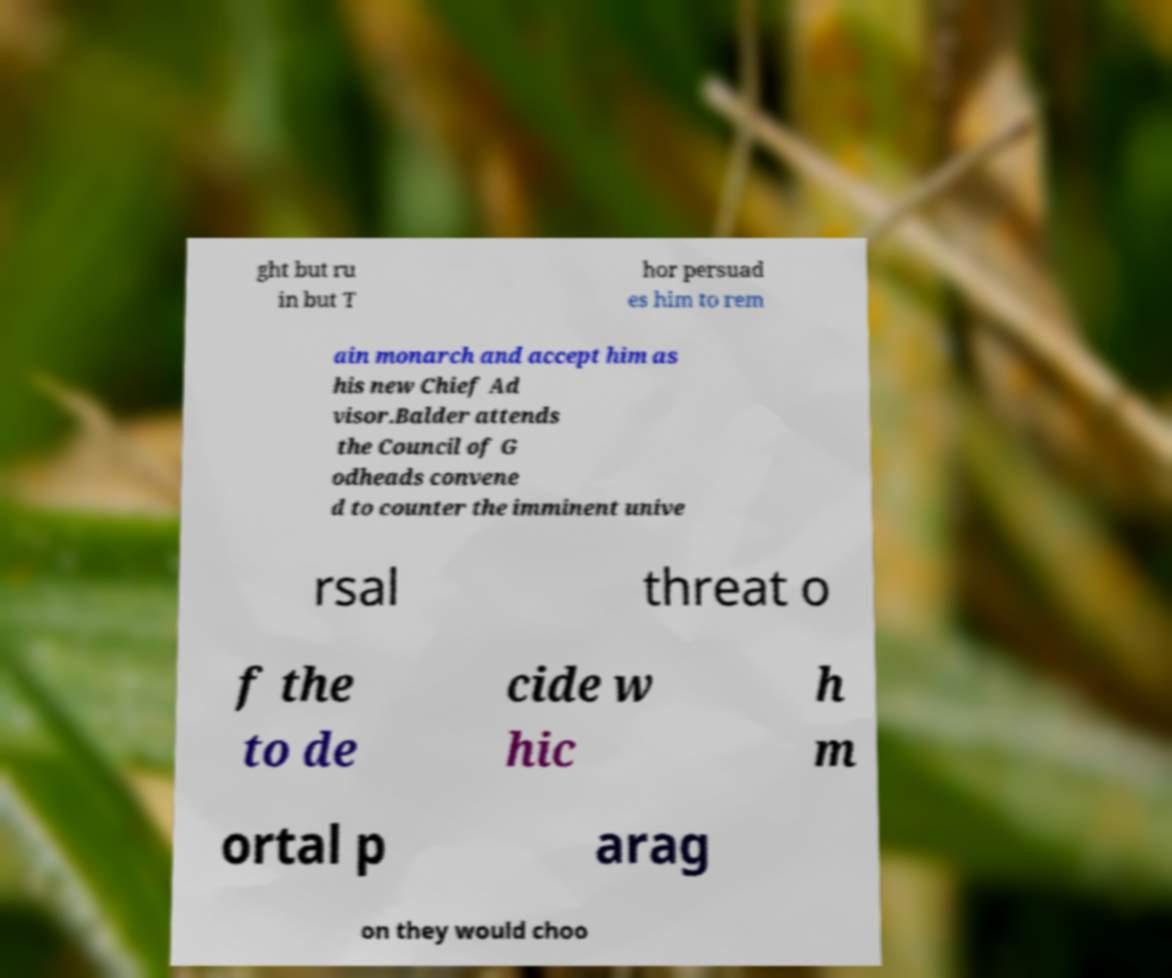Please read and relay the text visible in this image. What does it say? ght but ru in but T hor persuad es him to rem ain monarch and accept him as his new Chief Ad visor.Balder attends the Council of G odheads convene d to counter the imminent unive rsal threat o f the to de cide w hic h m ortal p arag on they would choo 